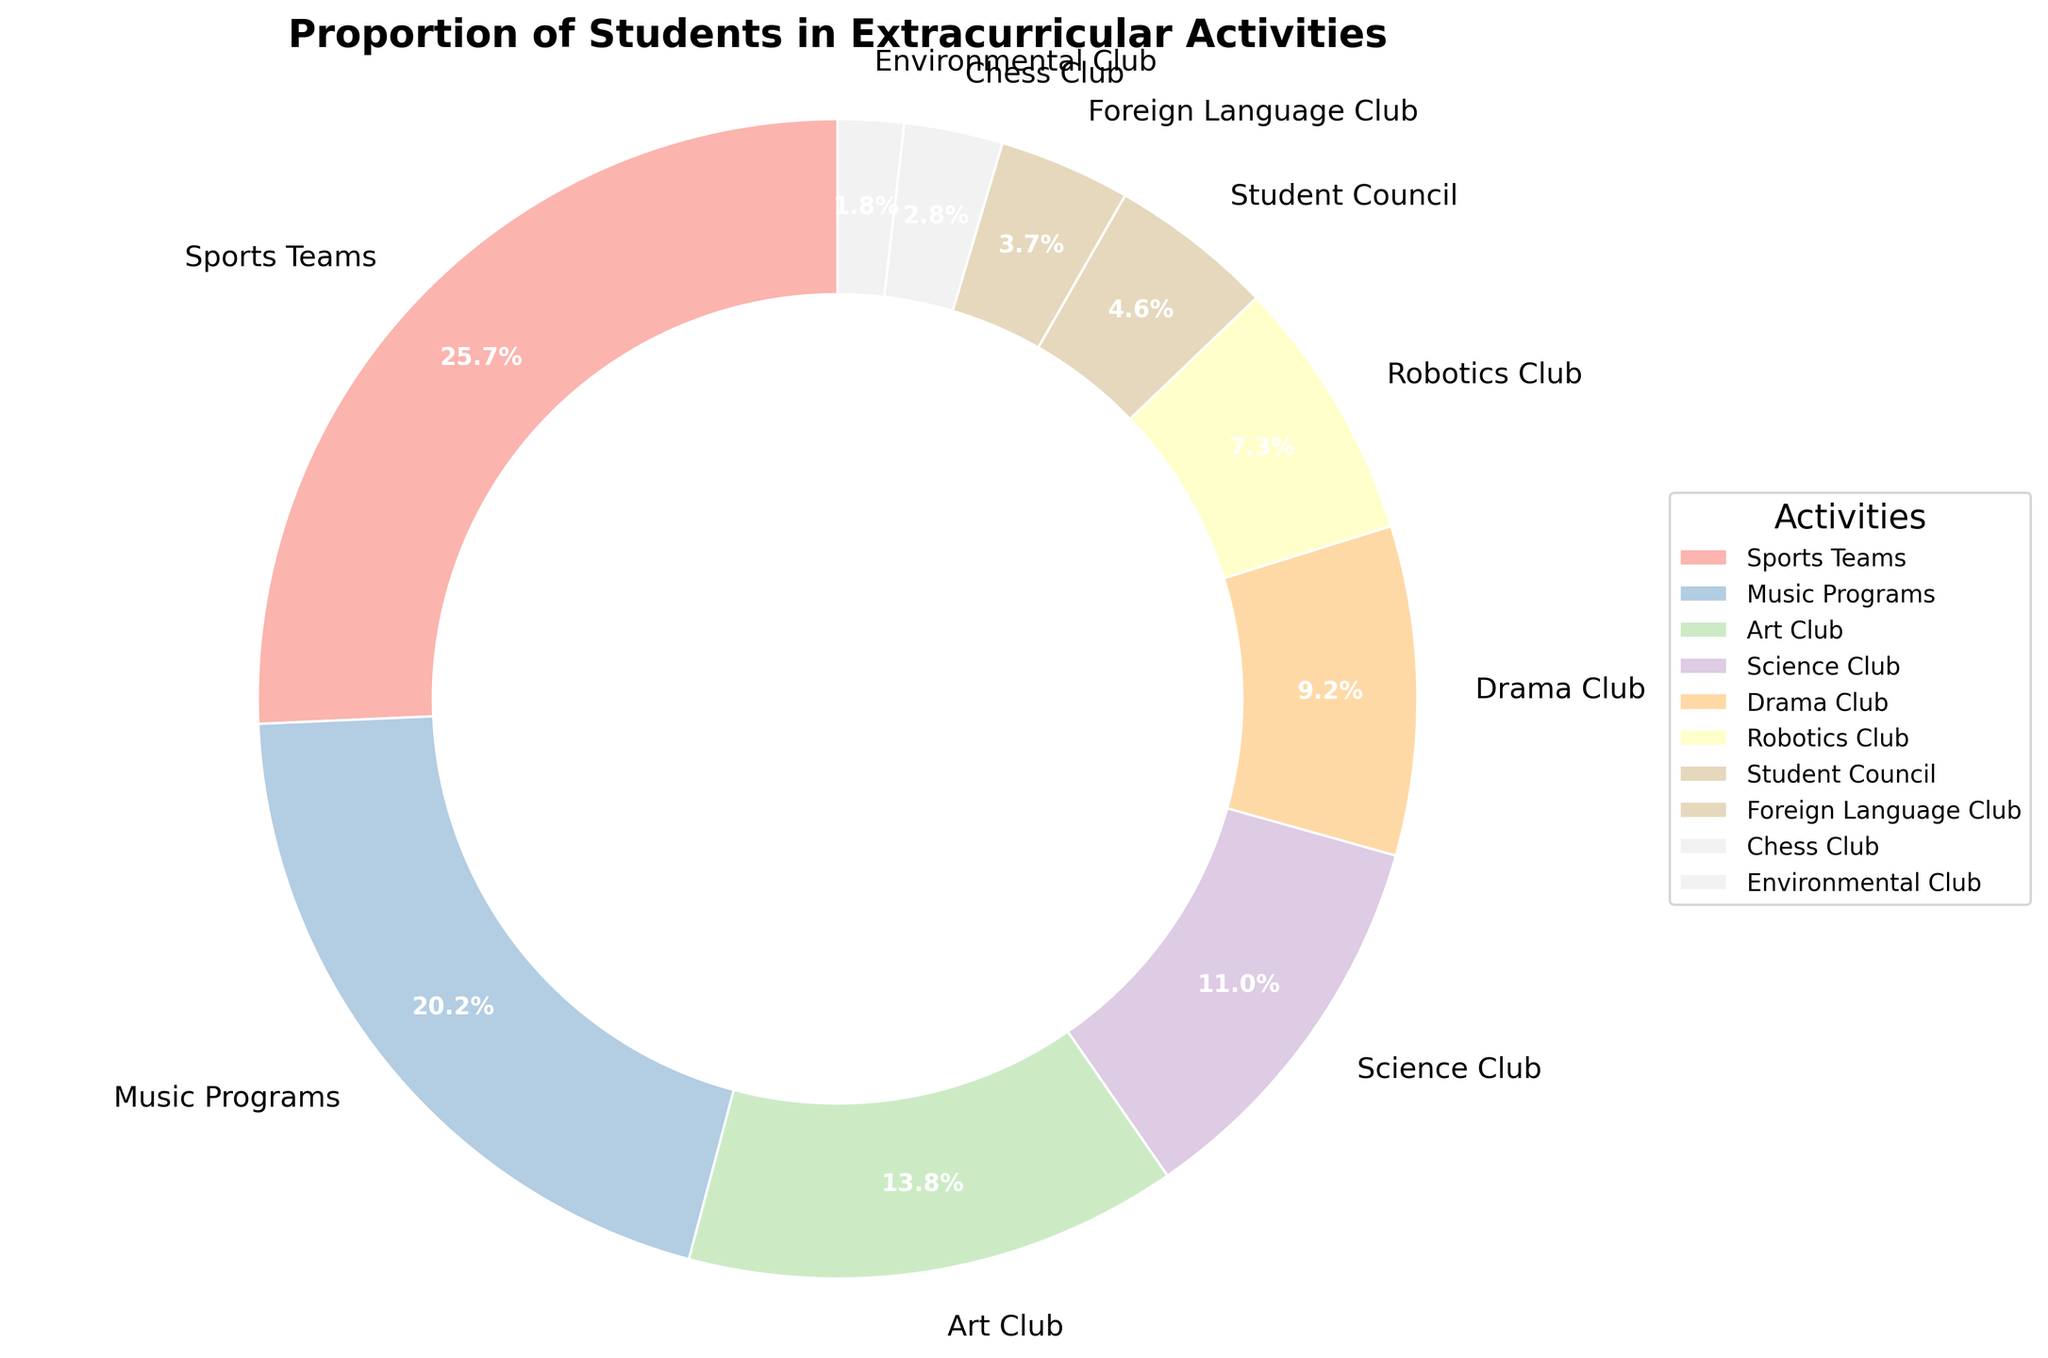Which activity has the highest participation percentage? The wedge with the label "Sports Teams" covers the largest portion of the pie chart, indicating it has the highest percentage.
Answer: Sports Teams What is the combined percentage of students participating in Drama Club and Robotics Club? The percentages for Drama Club and Robotics Club are 10% and 8%, respectively. Adding these together gives 10% + 8% = 18%.
Answer: 18% Which activity has a larger participation rate: Art Club or Science Club? By comparing the sizes of the respective wedges, Art Club has a participation rate of 15% while Science Club has 12%. Therefore, Art Club has a larger participation rate.
Answer: Art Club How many activities have a participation percentage lower than 10%? The activities with percentages lower than 10% are Drama Club (10% is not less than 10%), Robotics Club (8%), Student Council (5%), Foreign Language Club (4%), Chess Club (3%), and Environmental Club (2%). There are 6 such activities.
Answer: 6 Is the participation in Music Programs greater than the combined participation in Chess Club and Environmental Club? Music Programs has a percentage of 22%. The combined percentage for Chess Club and Environmental Club is 3% + 2% = 5%. Since 22% is greater than 5%, the participation in Music Programs is greater.
Answer: Yes What is the difference in participation percentage between the highest and lowest activities? The highest participation percentage is for Sports Teams at 28%, and the lowest is for Environmental Club at 2%. The difference is 28% - 2% = 26%.
Answer: 26% Which activity has the smallest participation percentage and what is it? The wedge with the label "Environmental Club" covers the smallest portion of the pie chart, indicating it has the smallest percentage. The percentage is 2%.
Answer: Environmental Club, 2% Is the participation in Student Council nearly half of that in Music Programs? The percentage for Music Programs is 22%. Half of 22% is 11%. The participation percentage for Student Council is 5%, which is less than half of 11%.
Answer: No What are the three extracurricular activities with the highest participation percentages? The three largest wedges in the pie chart are labeled Sports Teams (28%), Music Programs (22%), and Art Club (15%).
Answer: Sports Teams, Music Programs, Art Club 